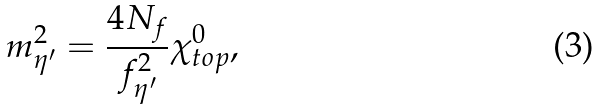<formula> <loc_0><loc_0><loc_500><loc_500>m _ { \eta ^ { \prime } } ^ { 2 } = \frac { 4 N _ { f } } { f _ { \eta ^ { \prime } } ^ { 2 } } \chi _ { t o p } ^ { 0 } ,</formula> 